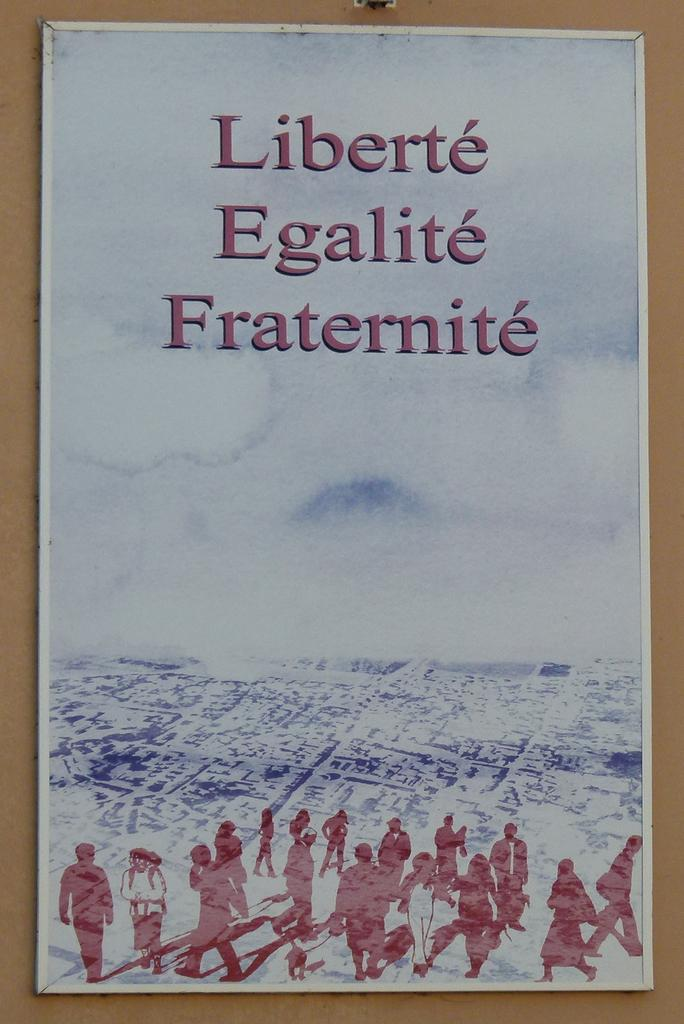<image>
Give a short and clear explanation of the subsequent image. a poster on a wall that says 'liberte egalite fraternite' 